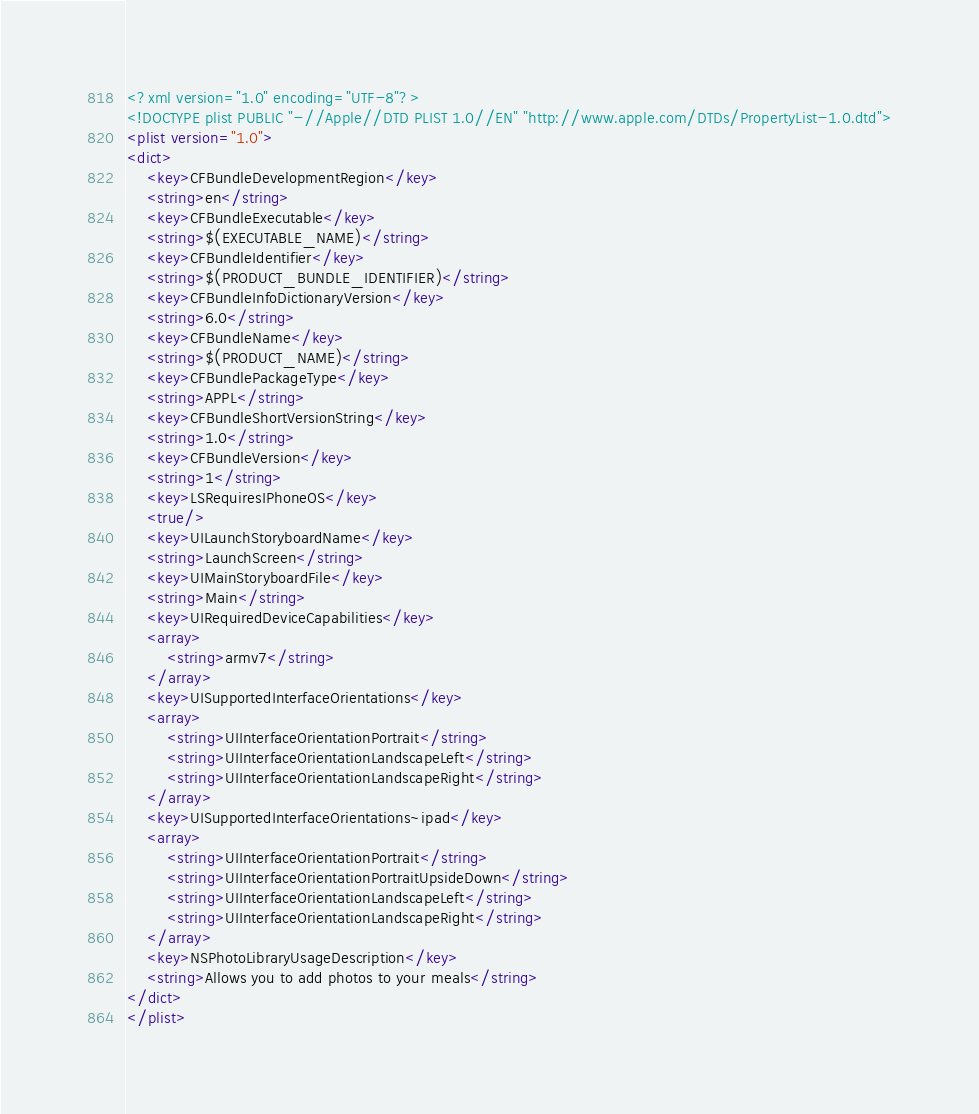Convert code to text. <code><loc_0><loc_0><loc_500><loc_500><_XML_><?xml version="1.0" encoding="UTF-8"?>
<!DOCTYPE plist PUBLIC "-//Apple//DTD PLIST 1.0//EN" "http://www.apple.com/DTDs/PropertyList-1.0.dtd">
<plist version="1.0">
<dict>
	<key>CFBundleDevelopmentRegion</key>
	<string>en</string>
	<key>CFBundleExecutable</key>
	<string>$(EXECUTABLE_NAME)</string>
	<key>CFBundleIdentifier</key>
	<string>$(PRODUCT_BUNDLE_IDENTIFIER)</string>
	<key>CFBundleInfoDictionaryVersion</key>
	<string>6.0</string>
	<key>CFBundleName</key>
	<string>$(PRODUCT_NAME)</string>
	<key>CFBundlePackageType</key>
	<string>APPL</string>
	<key>CFBundleShortVersionString</key>
	<string>1.0</string>
	<key>CFBundleVersion</key>
	<string>1</string>
	<key>LSRequiresIPhoneOS</key>
	<true/>
	<key>UILaunchStoryboardName</key>
	<string>LaunchScreen</string>
	<key>UIMainStoryboardFile</key>
	<string>Main</string>
	<key>UIRequiredDeviceCapabilities</key>
	<array>
		<string>armv7</string>
	</array>
	<key>UISupportedInterfaceOrientations</key>
	<array>
		<string>UIInterfaceOrientationPortrait</string>
		<string>UIInterfaceOrientationLandscapeLeft</string>
		<string>UIInterfaceOrientationLandscapeRight</string>
	</array>
	<key>UISupportedInterfaceOrientations~ipad</key>
	<array>
		<string>UIInterfaceOrientationPortrait</string>
		<string>UIInterfaceOrientationPortraitUpsideDown</string>
		<string>UIInterfaceOrientationLandscapeLeft</string>
		<string>UIInterfaceOrientationLandscapeRight</string>
	</array>
	<key>NSPhotoLibraryUsageDescription</key>
	<string>Allows you to add photos to your meals</string>
</dict>
</plist>
</code> 